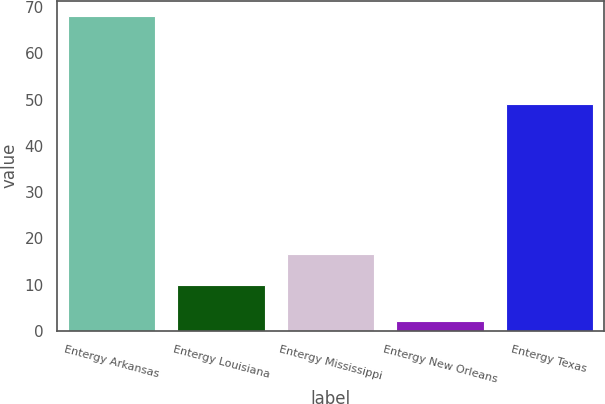<chart> <loc_0><loc_0><loc_500><loc_500><bar_chart><fcel>Entergy Arkansas<fcel>Entergy Louisiana<fcel>Entergy Mississippi<fcel>Entergy New Orleans<fcel>Entergy Texas<nl><fcel>68<fcel>10<fcel>16.6<fcel>2<fcel>49<nl></chart> 